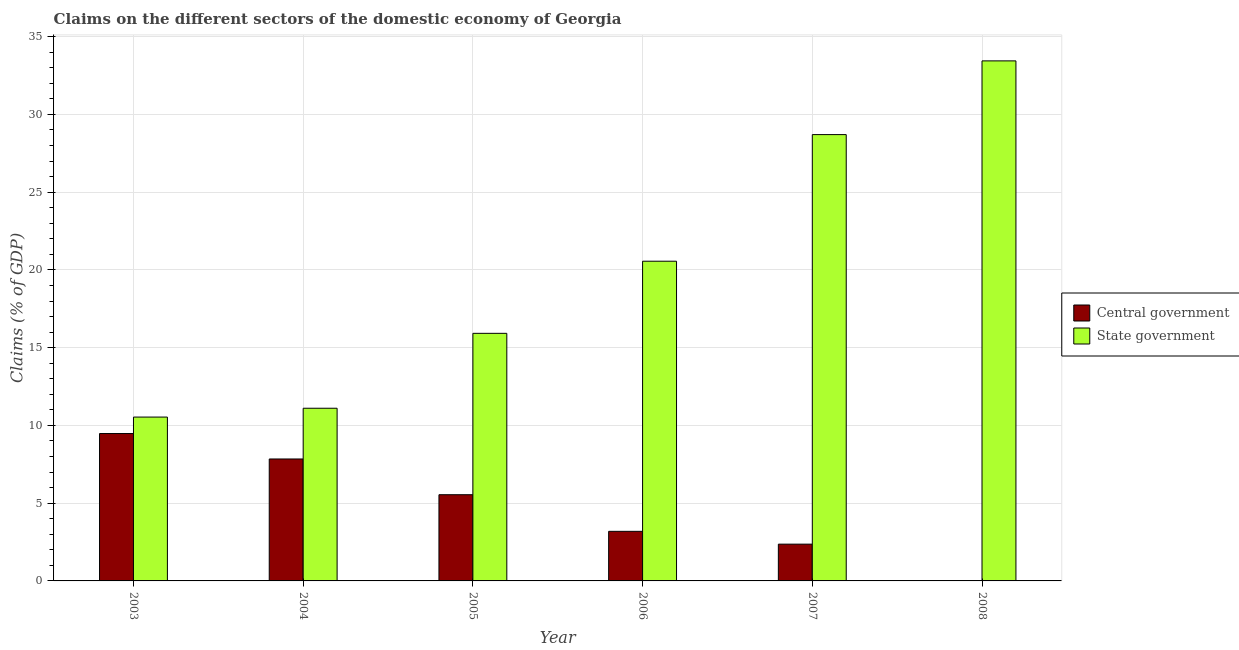Are the number of bars on each tick of the X-axis equal?
Your response must be concise. No. What is the claims on central government in 2006?
Provide a short and direct response. 3.19. Across all years, what is the maximum claims on state government?
Offer a very short reply. 33.44. Across all years, what is the minimum claims on state government?
Your response must be concise. 10.54. In which year was the claims on central government maximum?
Offer a terse response. 2003. What is the total claims on state government in the graph?
Provide a short and direct response. 120.27. What is the difference between the claims on state government in 2007 and that in 2008?
Provide a short and direct response. -4.74. What is the difference between the claims on state government in 2008 and the claims on central government in 2006?
Keep it short and to the point. 12.88. What is the average claims on central government per year?
Ensure brevity in your answer.  4.74. In the year 2004, what is the difference between the claims on state government and claims on central government?
Your answer should be very brief. 0. In how many years, is the claims on state government greater than 30 %?
Provide a succinct answer. 1. What is the ratio of the claims on state government in 2003 to that in 2006?
Keep it short and to the point. 0.51. Is the claims on central government in 2006 less than that in 2007?
Your answer should be very brief. No. Is the difference between the claims on central government in 2005 and 2007 greater than the difference between the claims on state government in 2005 and 2007?
Your response must be concise. No. What is the difference between the highest and the second highest claims on central government?
Provide a short and direct response. 1.64. What is the difference between the highest and the lowest claims on central government?
Give a very brief answer. 9.48. In how many years, is the claims on state government greater than the average claims on state government taken over all years?
Make the answer very short. 3. How many bars are there?
Offer a terse response. 11. Are all the bars in the graph horizontal?
Give a very brief answer. No. How many years are there in the graph?
Your answer should be very brief. 6. What is the difference between two consecutive major ticks on the Y-axis?
Your answer should be compact. 5. Are the values on the major ticks of Y-axis written in scientific E-notation?
Offer a very short reply. No. Does the graph contain any zero values?
Your answer should be compact. Yes. Where does the legend appear in the graph?
Your answer should be compact. Center right. What is the title of the graph?
Make the answer very short. Claims on the different sectors of the domestic economy of Georgia. Does "Investment in Telecom" appear as one of the legend labels in the graph?
Your answer should be compact. No. What is the label or title of the X-axis?
Provide a short and direct response. Year. What is the label or title of the Y-axis?
Provide a short and direct response. Claims (% of GDP). What is the Claims (% of GDP) in Central government in 2003?
Provide a succinct answer. 9.48. What is the Claims (% of GDP) of State government in 2003?
Your answer should be compact. 10.54. What is the Claims (% of GDP) of Central government in 2004?
Your answer should be very brief. 7.84. What is the Claims (% of GDP) of State government in 2004?
Ensure brevity in your answer.  11.1. What is the Claims (% of GDP) in Central government in 2005?
Offer a terse response. 5.54. What is the Claims (% of GDP) in State government in 2005?
Give a very brief answer. 15.92. What is the Claims (% of GDP) in Central government in 2006?
Your response must be concise. 3.19. What is the Claims (% of GDP) of State government in 2006?
Offer a terse response. 20.56. What is the Claims (% of GDP) in Central government in 2007?
Your answer should be compact. 2.37. What is the Claims (% of GDP) of State government in 2007?
Provide a succinct answer. 28.7. What is the Claims (% of GDP) of State government in 2008?
Offer a terse response. 33.44. Across all years, what is the maximum Claims (% of GDP) in Central government?
Make the answer very short. 9.48. Across all years, what is the maximum Claims (% of GDP) in State government?
Your answer should be compact. 33.44. Across all years, what is the minimum Claims (% of GDP) of State government?
Make the answer very short. 10.54. What is the total Claims (% of GDP) of Central government in the graph?
Keep it short and to the point. 28.42. What is the total Claims (% of GDP) of State government in the graph?
Your answer should be compact. 120.27. What is the difference between the Claims (% of GDP) of Central government in 2003 and that in 2004?
Your response must be concise. 1.64. What is the difference between the Claims (% of GDP) of State government in 2003 and that in 2004?
Give a very brief answer. -0.57. What is the difference between the Claims (% of GDP) in Central government in 2003 and that in 2005?
Provide a succinct answer. 3.93. What is the difference between the Claims (% of GDP) in State government in 2003 and that in 2005?
Offer a terse response. -5.38. What is the difference between the Claims (% of GDP) in Central government in 2003 and that in 2006?
Offer a terse response. 6.29. What is the difference between the Claims (% of GDP) in State government in 2003 and that in 2006?
Keep it short and to the point. -10.02. What is the difference between the Claims (% of GDP) of Central government in 2003 and that in 2007?
Your answer should be very brief. 7.11. What is the difference between the Claims (% of GDP) in State government in 2003 and that in 2007?
Ensure brevity in your answer.  -18.16. What is the difference between the Claims (% of GDP) of State government in 2003 and that in 2008?
Make the answer very short. -22.91. What is the difference between the Claims (% of GDP) of Central government in 2004 and that in 2005?
Offer a very short reply. 2.3. What is the difference between the Claims (% of GDP) of State government in 2004 and that in 2005?
Make the answer very short. -4.82. What is the difference between the Claims (% of GDP) in Central government in 2004 and that in 2006?
Keep it short and to the point. 4.65. What is the difference between the Claims (% of GDP) in State government in 2004 and that in 2006?
Give a very brief answer. -9.46. What is the difference between the Claims (% of GDP) of Central government in 2004 and that in 2007?
Your answer should be compact. 5.48. What is the difference between the Claims (% of GDP) in State government in 2004 and that in 2007?
Make the answer very short. -17.6. What is the difference between the Claims (% of GDP) of State government in 2004 and that in 2008?
Provide a short and direct response. -22.34. What is the difference between the Claims (% of GDP) in Central government in 2005 and that in 2006?
Provide a succinct answer. 2.35. What is the difference between the Claims (% of GDP) of State government in 2005 and that in 2006?
Offer a very short reply. -4.64. What is the difference between the Claims (% of GDP) in Central government in 2005 and that in 2007?
Make the answer very short. 3.18. What is the difference between the Claims (% of GDP) of State government in 2005 and that in 2007?
Your response must be concise. -12.78. What is the difference between the Claims (% of GDP) in State government in 2005 and that in 2008?
Give a very brief answer. -17.52. What is the difference between the Claims (% of GDP) in Central government in 2006 and that in 2007?
Provide a short and direct response. 0.82. What is the difference between the Claims (% of GDP) of State government in 2006 and that in 2007?
Ensure brevity in your answer.  -8.14. What is the difference between the Claims (% of GDP) in State government in 2006 and that in 2008?
Your response must be concise. -12.88. What is the difference between the Claims (% of GDP) in State government in 2007 and that in 2008?
Your answer should be compact. -4.74. What is the difference between the Claims (% of GDP) of Central government in 2003 and the Claims (% of GDP) of State government in 2004?
Provide a succinct answer. -1.63. What is the difference between the Claims (% of GDP) of Central government in 2003 and the Claims (% of GDP) of State government in 2005?
Offer a terse response. -6.44. What is the difference between the Claims (% of GDP) in Central government in 2003 and the Claims (% of GDP) in State government in 2006?
Make the answer very short. -11.08. What is the difference between the Claims (% of GDP) of Central government in 2003 and the Claims (% of GDP) of State government in 2007?
Offer a terse response. -19.22. What is the difference between the Claims (% of GDP) in Central government in 2003 and the Claims (% of GDP) in State government in 2008?
Your response must be concise. -23.96. What is the difference between the Claims (% of GDP) in Central government in 2004 and the Claims (% of GDP) in State government in 2005?
Provide a short and direct response. -8.08. What is the difference between the Claims (% of GDP) in Central government in 2004 and the Claims (% of GDP) in State government in 2006?
Provide a short and direct response. -12.72. What is the difference between the Claims (% of GDP) in Central government in 2004 and the Claims (% of GDP) in State government in 2007?
Offer a very short reply. -20.86. What is the difference between the Claims (% of GDP) of Central government in 2004 and the Claims (% of GDP) of State government in 2008?
Ensure brevity in your answer.  -25.6. What is the difference between the Claims (% of GDP) of Central government in 2005 and the Claims (% of GDP) of State government in 2006?
Your answer should be very brief. -15.02. What is the difference between the Claims (% of GDP) of Central government in 2005 and the Claims (% of GDP) of State government in 2007?
Offer a terse response. -23.16. What is the difference between the Claims (% of GDP) in Central government in 2005 and the Claims (% of GDP) in State government in 2008?
Give a very brief answer. -27.9. What is the difference between the Claims (% of GDP) of Central government in 2006 and the Claims (% of GDP) of State government in 2007?
Offer a terse response. -25.51. What is the difference between the Claims (% of GDP) in Central government in 2006 and the Claims (% of GDP) in State government in 2008?
Keep it short and to the point. -30.25. What is the difference between the Claims (% of GDP) in Central government in 2007 and the Claims (% of GDP) in State government in 2008?
Provide a short and direct response. -31.08. What is the average Claims (% of GDP) of Central government per year?
Your answer should be compact. 4.74. What is the average Claims (% of GDP) in State government per year?
Provide a short and direct response. 20.04. In the year 2003, what is the difference between the Claims (% of GDP) in Central government and Claims (% of GDP) in State government?
Provide a short and direct response. -1.06. In the year 2004, what is the difference between the Claims (% of GDP) of Central government and Claims (% of GDP) of State government?
Make the answer very short. -3.26. In the year 2005, what is the difference between the Claims (% of GDP) of Central government and Claims (% of GDP) of State government?
Make the answer very short. -10.38. In the year 2006, what is the difference between the Claims (% of GDP) of Central government and Claims (% of GDP) of State government?
Provide a short and direct response. -17.37. In the year 2007, what is the difference between the Claims (% of GDP) of Central government and Claims (% of GDP) of State government?
Your answer should be very brief. -26.34. What is the ratio of the Claims (% of GDP) in Central government in 2003 to that in 2004?
Keep it short and to the point. 1.21. What is the ratio of the Claims (% of GDP) of State government in 2003 to that in 2004?
Keep it short and to the point. 0.95. What is the ratio of the Claims (% of GDP) in Central government in 2003 to that in 2005?
Make the answer very short. 1.71. What is the ratio of the Claims (% of GDP) in State government in 2003 to that in 2005?
Your answer should be compact. 0.66. What is the ratio of the Claims (% of GDP) of Central government in 2003 to that in 2006?
Your response must be concise. 2.97. What is the ratio of the Claims (% of GDP) in State government in 2003 to that in 2006?
Ensure brevity in your answer.  0.51. What is the ratio of the Claims (% of GDP) in Central government in 2003 to that in 2007?
Keep it short and to the point. 4.01. What is the ratio of the Claims (% of GDP) in State government in 2003 to that in 2007?
Your response must be concise. 0.37. What is the ratio of the Claims (% of GDP) of State government in 2003 to that in 2008?
Your response must be concise. 0.32. What is the ratio of the Claims (% of GDP) of Central government in 2004 to that in 2005?
Offer a terse response. 1.41. What is the ratio of the Claims (% of GDP) of State government in 2004 to that in 2005?
Your answer should be very brief. 0.7. What is the ratio of the Claims (% of GDP) in Central government in 2004 to that in 2006?
Offer a terse response. 2.46. What is the ratio of the Claims (% of GDP) of State government in 2004 to that in 2006?
Ensure brevity in your answer.  0.54. What is the ratio of the Claims (% of GDP) in Central government in 2004 to that in 2007?
Provide a short and direct response. 3.32. What is the ratio of the Claims (% of GDP) in State government in 2004 to that in 2007?
Your answer should be very brief. 0.39. What is the ratio of the Claims (% of GDP) of State government in 2004 to that in 2008?
Provide a short and direct response. 0.33. What is the ratio of the Claims (% of GDP) of Central government in 2005 to that in 2006?
Offer a very short reply. 1.74. What is the ratio of the Claims (% of GDP) in State government in 2005 to that in 2006?
Your answer should be very brief. 0.77. What is the ratio of the Claims (% of GDP) in Central government in 2005 to that in 2007?
Ensure brevity in your answer.  2.34. What is the ratio of the Claims (% of GDP) in State government in 2005 to that in 2007?
Offer a very short reply. 0.55. What is the ratio of the Claims (% of GDP) in State government in 2005 to that in 2008?
Keep it short and to the point. 0.48. What is the ratio of the Claims (% of GDP) of Central government in 2006 to that in 2007?
Ensure brevity in your answer.  1.35. What is the ratio of the Claims (% of GDP) of State government in 2006 to that in 2007?
Provide a short and direct response. 0.72. What is the ratio of the Claims (% of GDP) in State government in 2006 to that in 2008?
Make the answer very short. 0.61. What is the ratio of the Claims (% of GDP) of State government in 2007 to that in 2008?
Provide a short and direct response. 0.86. What is the difference between the highest and the second highest Claims (% of GDP) of Central government?
Ensure brevity in your answer.  1.64. What is the difference between the highest and the second highest Claims (% of GDP) in State government?
Provide a short and direct response. 4.74. What is the difference between the highest and the lowest Claims (% of GDP) of Central government?
Give a very brief answer. 9.48. What is the difference between the highest and the lowest Claims (% of GDP) in State government?
Offer a terse response. 22.91. 